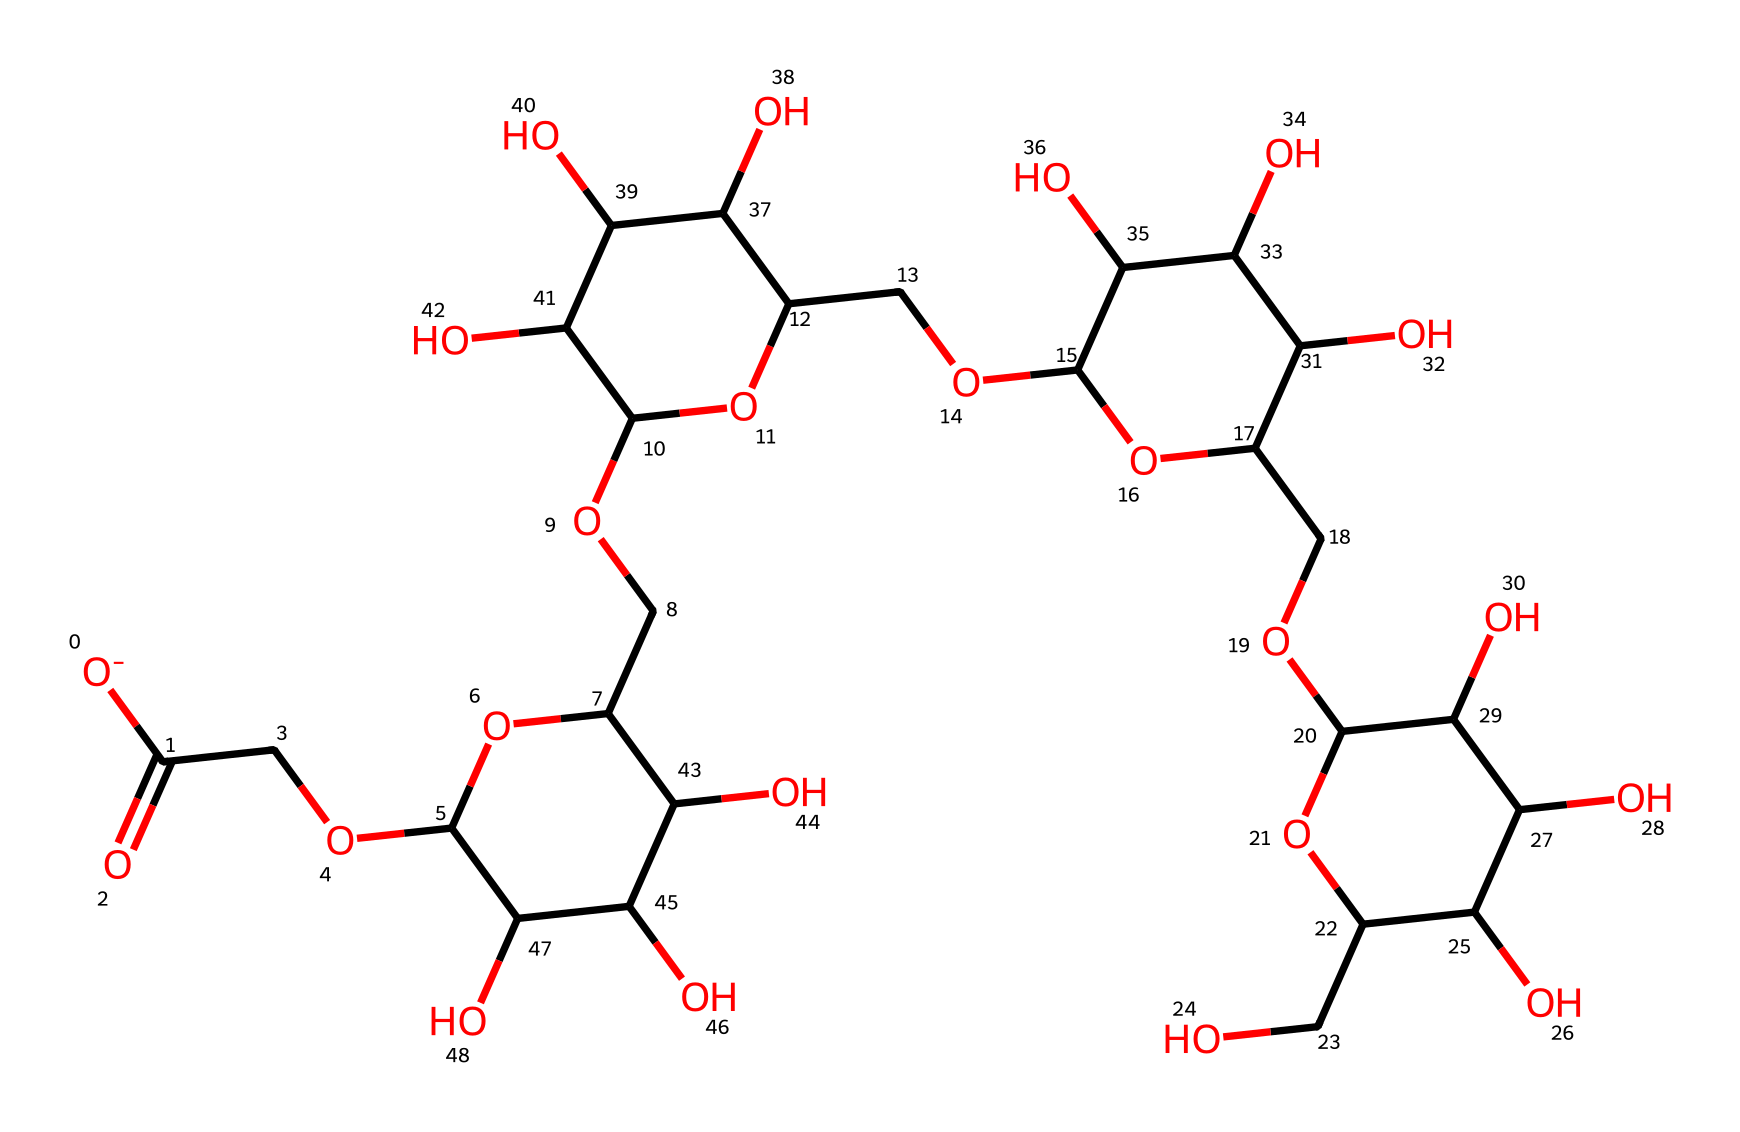What is the common name of this chemical? The SMILES representation corresponds to carboxymethylcellulose, commonly known as CMC, which is a food additive used as a thickening and stabilizing agent.
Answer: carboxymethylcellulose How many carbon atoms are present in the structure? By examining the SMILES representation, we can count the number of 'C' symbols, which indicates the presence of a total of 15 carbon atoms in the structure of carboxymethylcellulose.
Answer: 15 What types of functional groups are present? The structure contains hydroxyl groups (-OH) and a carboxymethyl group (-COO-). Hydroxyl groups can be identified by any 'O' following 'C' in the SMILES notation, indicating their presence.
Answer: hydroxyl and carboxymethyl How does carboxymethylcellulose interact with water? Carboxymethylcellulose is soluble in water due to its hydroxyl and carboxymethyl functional groups, which allow for hydrogen bonding with water molecules, facilitating hydration and thickening.
Answer: soluble What role does carboxymethylcellulose play in oral suspensions? In oral suspensions, carboxymethylcellulose acts as a stabilizer by maintaining the dispersion of particles and preventing sedimentation, ensuring uniformity in dosage.
Answer: stabilizer How many oxygen atoms are in the compound? Counting the 'O' symbols in the SMILES notation indicates that there are 6 oxygen atoms present in the molecule of carboxymethylcellulose.
Answer: 6 What makes carboxymethylcellulose a suitable food additive? Carboxymethylcellulose's ability to thicken, stabilize, and enhance texture while being non-toxic and safe for consumption makes it a suitable food additive in various formulations.
Answer: non-toxic and stabilizing 